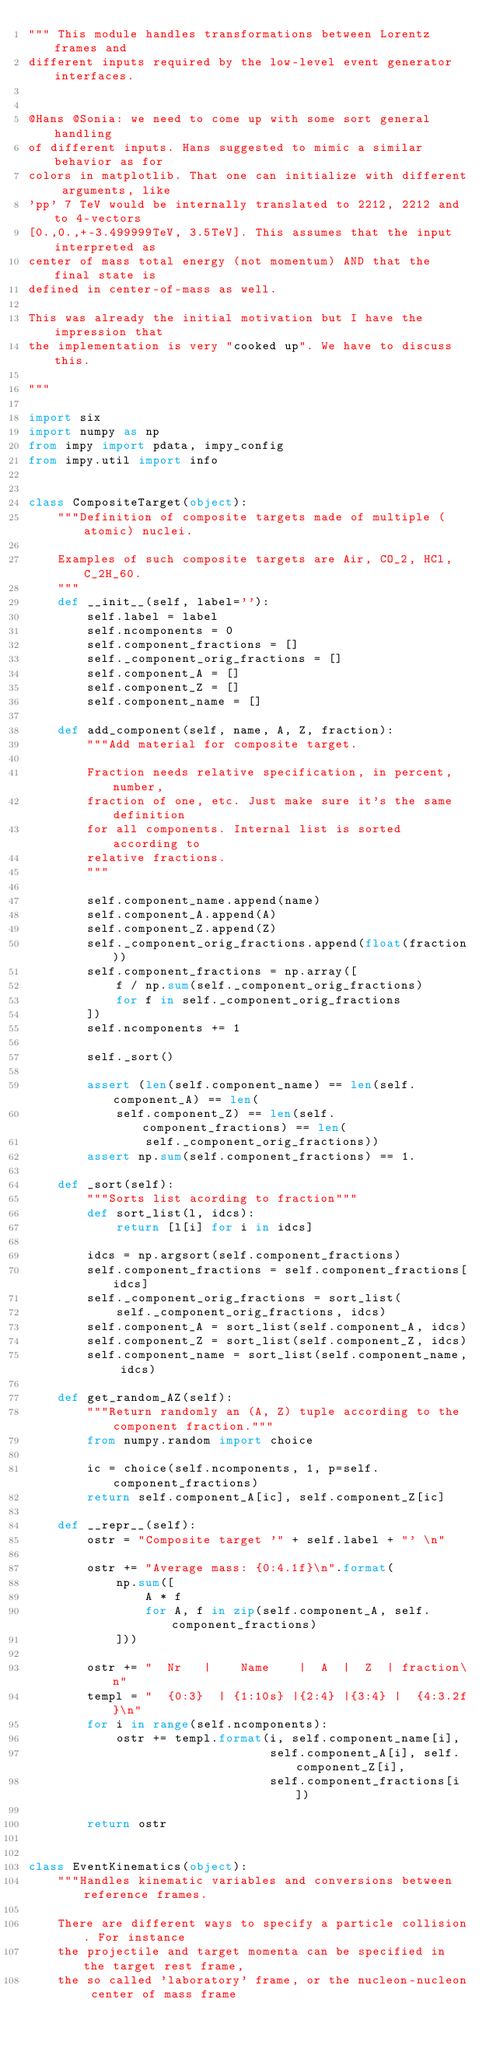<code> <loc_0><loc_0><loc_500><loc_500><_Python_>""" This module handles transformations between Lorentz frames and
different inputs required by the low-level event generator interfaces.


@Hans @Sonia: we need to come up with some sort general handling
of different inputs. Hans suggested to mimic a similar behavior as for
colors in matplotlib. That one can initialize with different arguments, like
'pp' 7 TeV would be internally translated to 2212, 2212 and to 4-vectors
[0.,0.,+-3.499999TeV, 3.5TeV]. This assumes that the input interpreted as
center of mass total energy (not momentum) AND that the final state is
defined in center-of-mass as well.

This was already the initial motivation but I have the impression that
the implementation is very "cooked up". We have to discuss this.

"""

import six
import numpy as np
from impy import pdata, impy_config
from impy.util import info


class CompositeTarget(object):
    """Definition of composite targets made of multiple (atomic) nuclei.

    Examples of such composite targets are Air, CO_2, HCl, C_2H_60.
    """
    def __init__(self, label=''):
        self.label = label
        self.ncomponents = 0
        self.component_fractions = []
        self._component_orig_fractions = []
        self.component_A = []
        self.component_Z = []
        self.component_name = []

    def add_component(self, name, A, Z, fraction):
        """Add material for composite target.

        Fraction needs relative specification, in percent, number,
        fraction of one, etc. Just make sure it's the same definition
        for all components. Internal list is sorted according to
        relative fractions.
        """

        self.component_name.append(name)
        self.component_A.append(A)
        self.component_Z.append(Z)
        self._component_orig_fractions.append(float(fraction))
        self.component_fractions = np.array([
            f / np.sum(self._component_orig_fractions)
            for f in self._component_orig_fractions
        ])
        self.ncomponents += 1

        self._sort()

        assert (len(self.component_name) == len(self.component_A) == len(
            self.component_Z) == len(self.component_fractions) == len(
                self._component_orig_fractions))
        assert np.sum(self.component_fractions) == 1.

    def _sort(self):
        """Sorts list acording to fraction"""
        def sort_list(l, idcs):
            return [l[i] for i in idcs]

        idcs = np.argsort(self.component_fractions)
        self.component_fractions = self.component_fractions[idcs]
        self._component_orig_fractions = sort_list(
            self._component_orig_fractions, idcs)
        self.component_A = sort_list(self.component_A, idcs)
        self.component_Z = sort_list(self.component_Z, idcs)
        self.component_name = sort_list(self.component_name, idcs)

    def get_random_AZ(self):
        """Return randomly an (A, Z) tuple according to the component fraction."""
        from numpy.random import choice

        ic = choice(self.ncomponents, 1, p=self.component_fractions)
        return self.component_A[ic], self.component_Z[ic]

    def __repr__(self):
        ostr = "Composite target '" + self.label + "' \n"

        ostr += "Average mass: {0:4.1f}\n".format(
            np.sum([
                A * f
                for A, f in zip(self.component_A, self.component_fractions)
            ]))

        ostr += "  Nr   |    Name    |  A  |  Z  | fraction\n"
        templ = "  {0:3}  | {1:10s} |{2:4} |{3:4} |  {4:3.2f}\n"
        for i in range(self.ncomponents):
            ostr += templ.format(i, self.component_name[i],
                                 self.component_A[i], self.component_Z[i],
                                 self.component_fractions[i])

        return ostr


class EventKinematics(object):
    """Handles kinematic variables and conversions between reference frames.

    There are different ways to specify a particle collision. For instance
    the projectile and target momenta can be specified in the target rest frame,
    the so called 'laboratory' frame, or the nucleon-nucleon center of mass frame</code> 